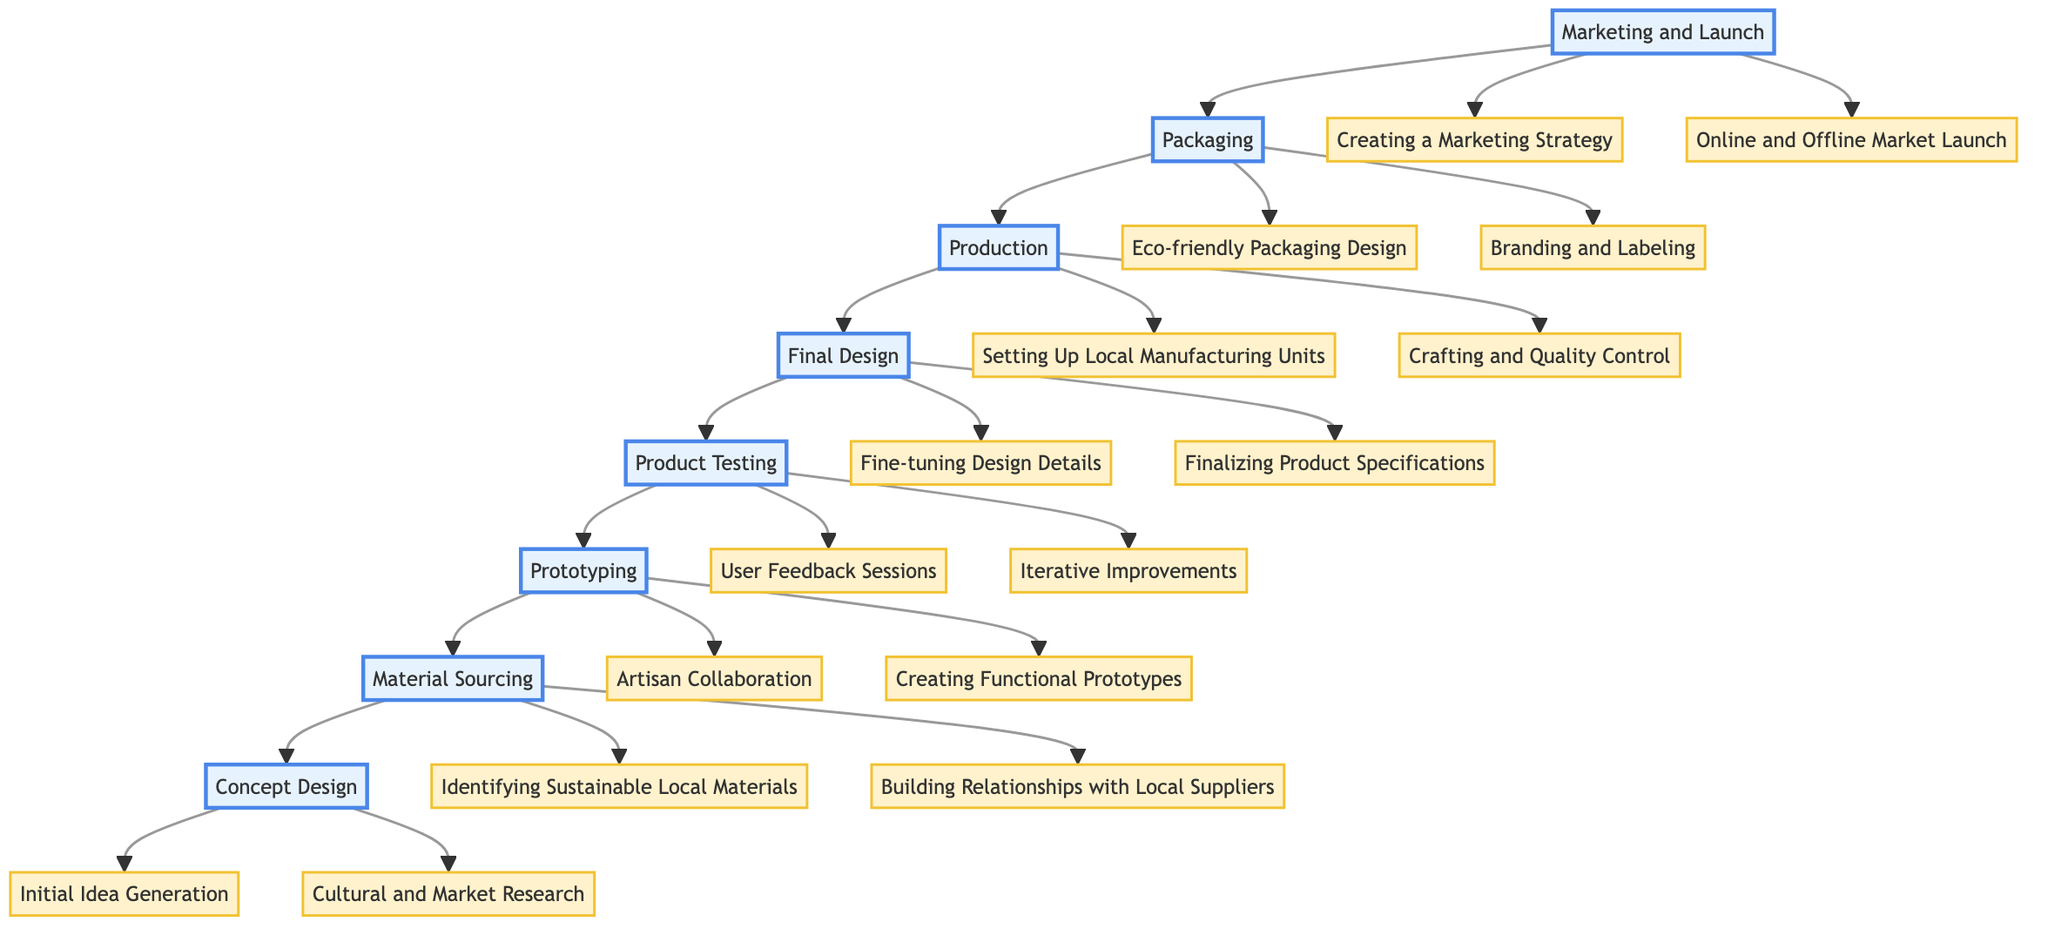What is the first stage in the journey? The first stage in the journey of a local craft item is at the bottom of the flow chart, which is labeled "Concept Design."
Answer: Concept Design How many activities are in the "Prototyping" stage? The "Prototyping" stage includes two activities: "Artisan Collaboration" and "Creating Functional Prototypes." Thus, there are 2 activities in this stage.
Answer: 2 What follows after "Final Design"? In the flow chart, "Final Design" is followed by the "Production" stage. This indicates the sequence of steps in the process.
Answer: Production Which stage has the activity "Creating a Marketing Strategy"? The activity "Creating a Marketing Strategy" is found in the "Marketing and Launch" stage. This is identified by checking the activities listed directly under that stage.
Answer: Marketing and Launch What is the last stage in the journey? The last stage in the journey of a local craft item, located at the top of the flow chart, is "Marketing and Launch."
Answer: Marketing and Launch Which two stages directly lead to "Product Testing"? The "Final Design" stage and its predecessor "Prototyping" both lead to "Product Testing." This requires following the arrows that connect these stages.
Answer: Prototyping, Final Design What type of material sourcing is emphasized in the process? The emphasis is on "Identifying Sustainable Local Materials," which highlights the focus on sustainability in the sourcing process.
Answer: Identifying Sustainable Local Materials What is the relationship between "Packaging" and "Marketing and Launch"? "Packaging" is a direct consequence or output of the "Marketing and Launch" stage, as indicated by the upward arrow connecting these two stages.
Answer: Packaging is part of Marketing and Launch How many total stages are in the diagram? By counting each of the main stages listed in the diagram, we find a total of 8 stages in the journey of a local craft item.
Answer: 8 